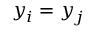Convert formula to latex. <formula><loc_0><loc_0><loc_500><loc_500>y _ { i } = y _ { j }</formula> 